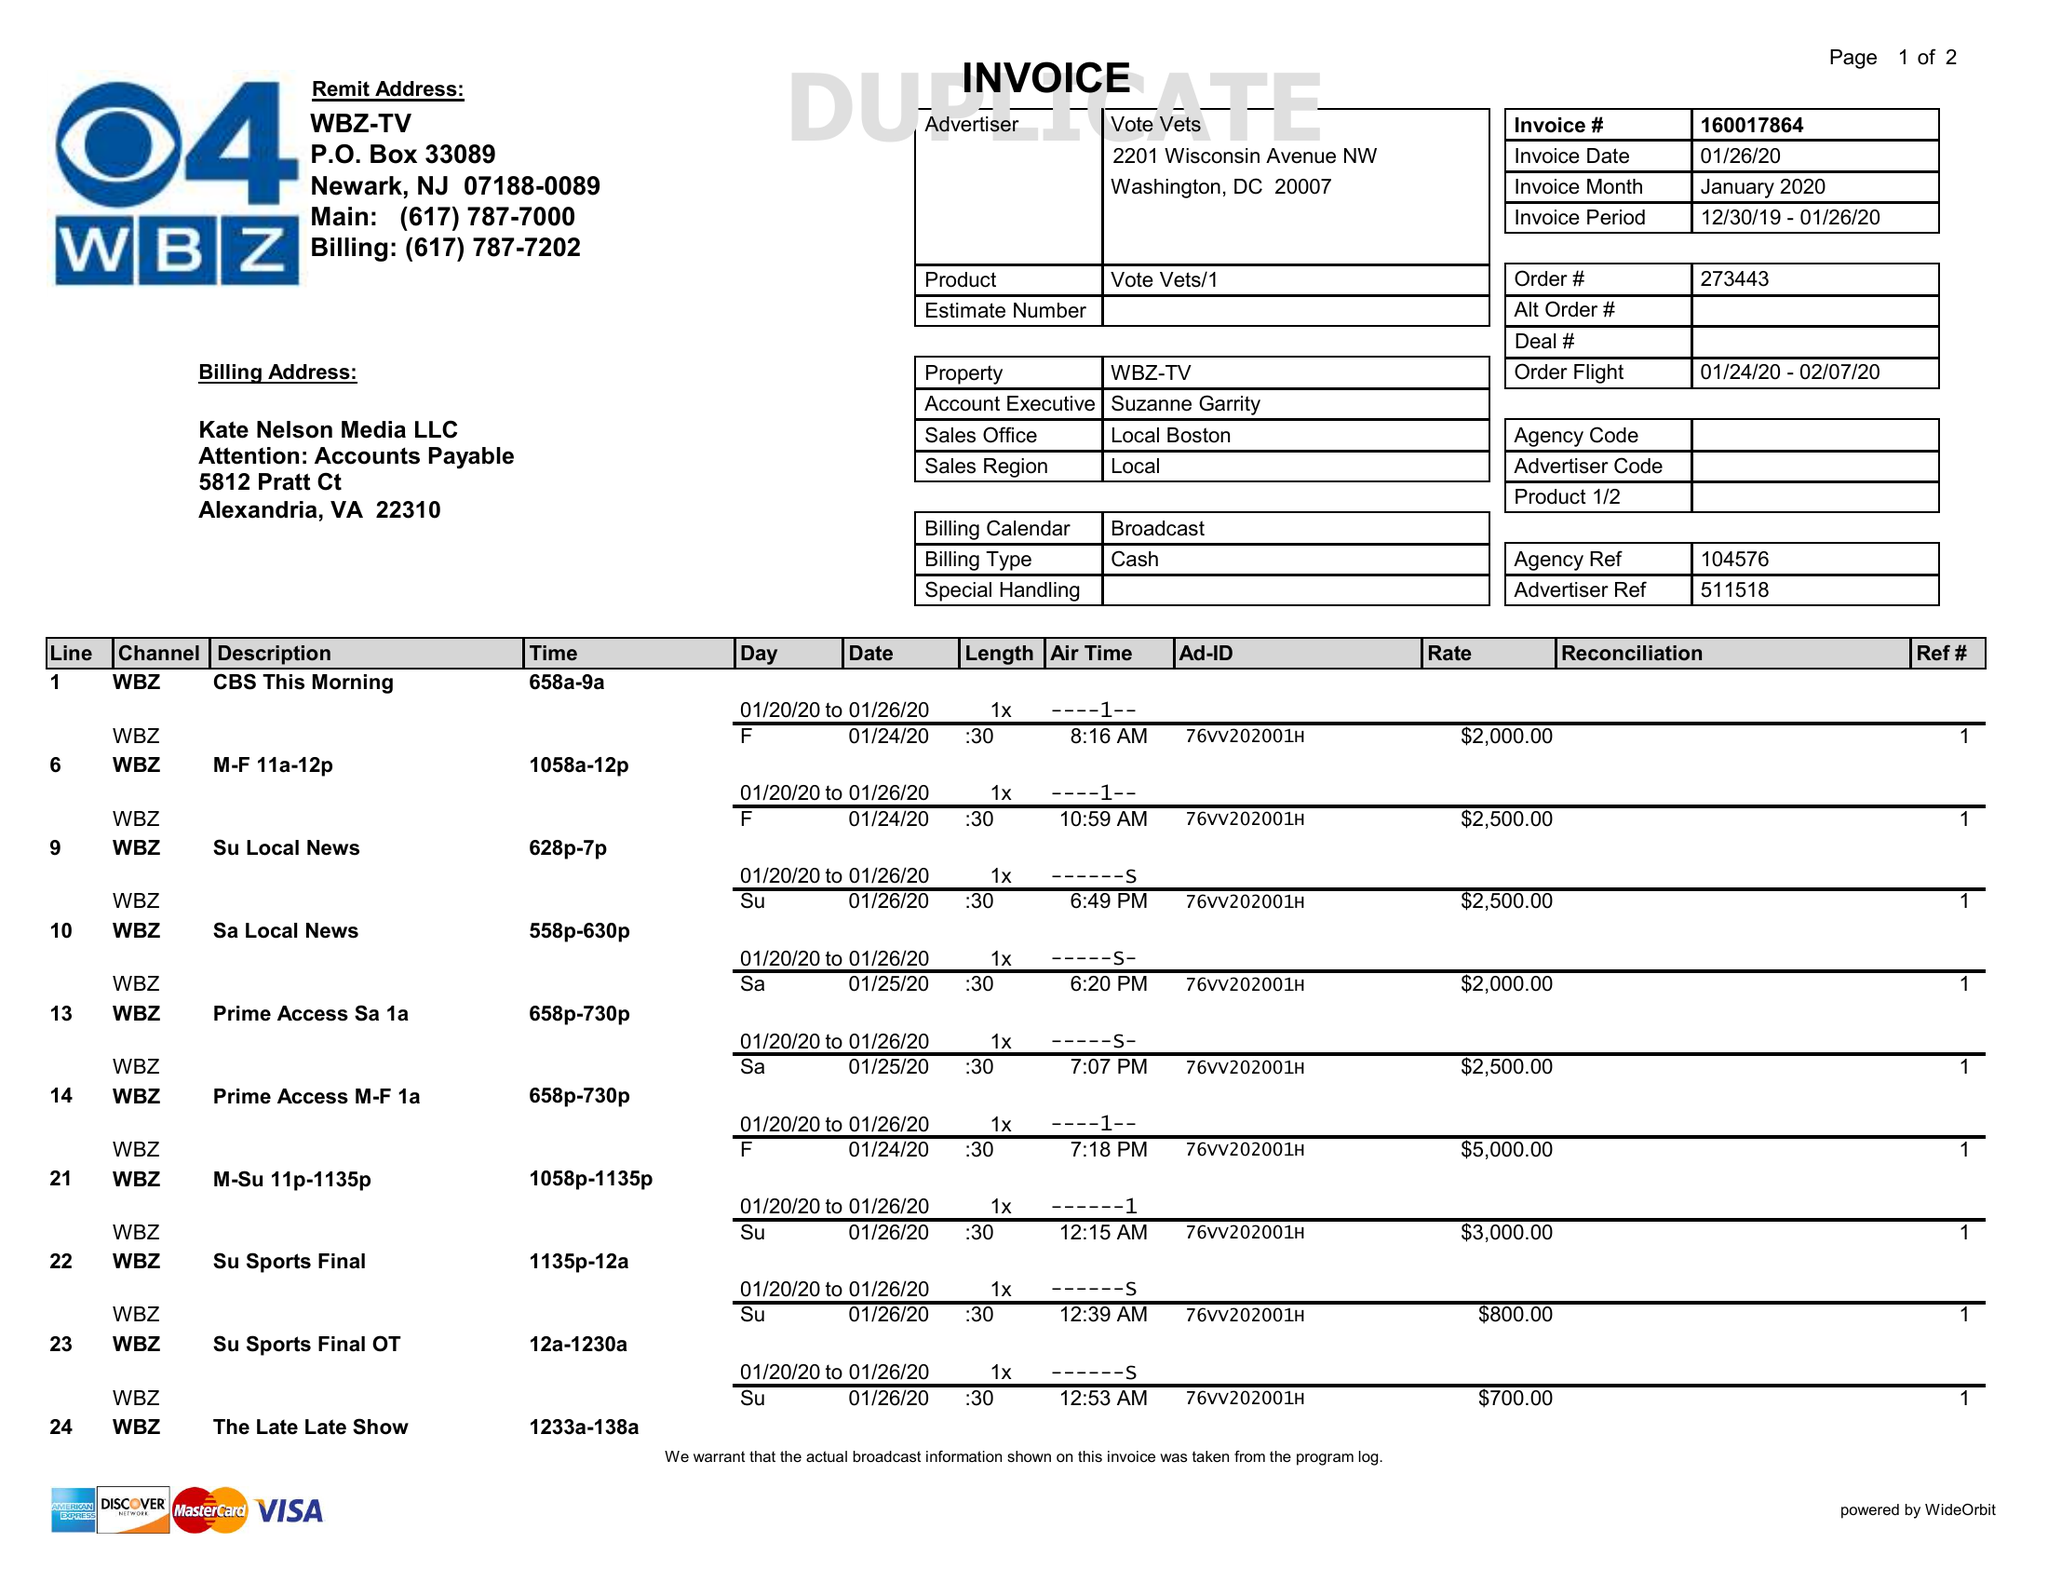What is the value for the flight_to?
Answer the question using a single word or phrase. 02/07/20 